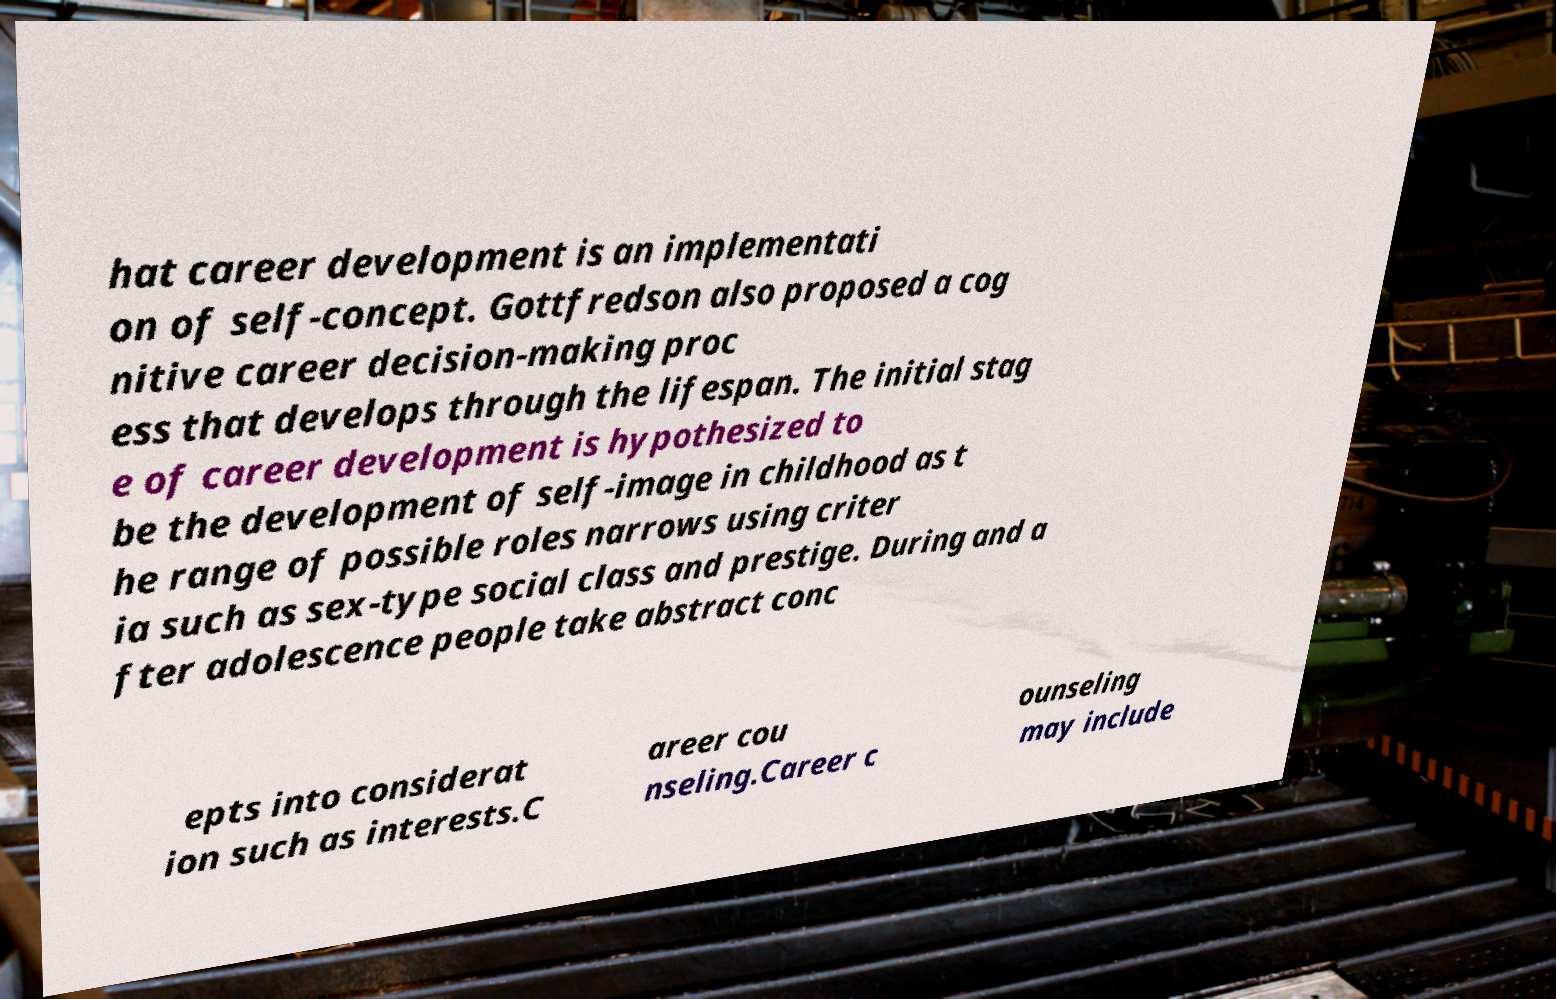Please identify and transcribe the text found in this image. hat career development is an implementati on of self-concept. Gottfredson also proposed a cog nitive career decision-making proc ess that develops through the lifespan. The initial stag e of career development is hypothesized to be the development of self-image in childhood as t he range of possible roles narrows using criter ia such as sex-type social class and prestige. During and a fter adolescence people take abstract conc epts into considerat ion such as interests.C areer cou nseling.Career c ounseling may include 